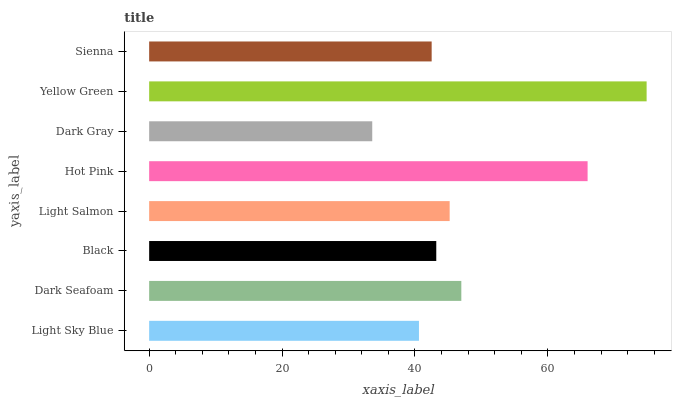Is Dark Gray the minimum?
Answer yes or no. Yes. Is Yellow Green the maximum?
Answer yes or no. Yes. Is Dark Seafoam the minimum?
Answer yes or no. No. Is Dark Seafoam the maximum?
Answer yes or no. No. Is Dark Seafoam greater than Light Sky Blue?
Answer yes or no. Yes. Is Light Sky Blue less than Dark Seafoam?
Answer yes or no. Yes. Is Light Sky Blue greater than Dark Seafoam?
Answer yes or no. No. Is Dark Seafoam less than Light Sky Blue?
Answer yes or no. No. Is Light Salmon the high median?
Answer yes or no. Yes. Is Black the low median?
Answer yes or no. Yes. Is Dark Gray the high median?
Answer yes or no. No. Is Light Sky Blue the low median?
Answer yes or no. No. 